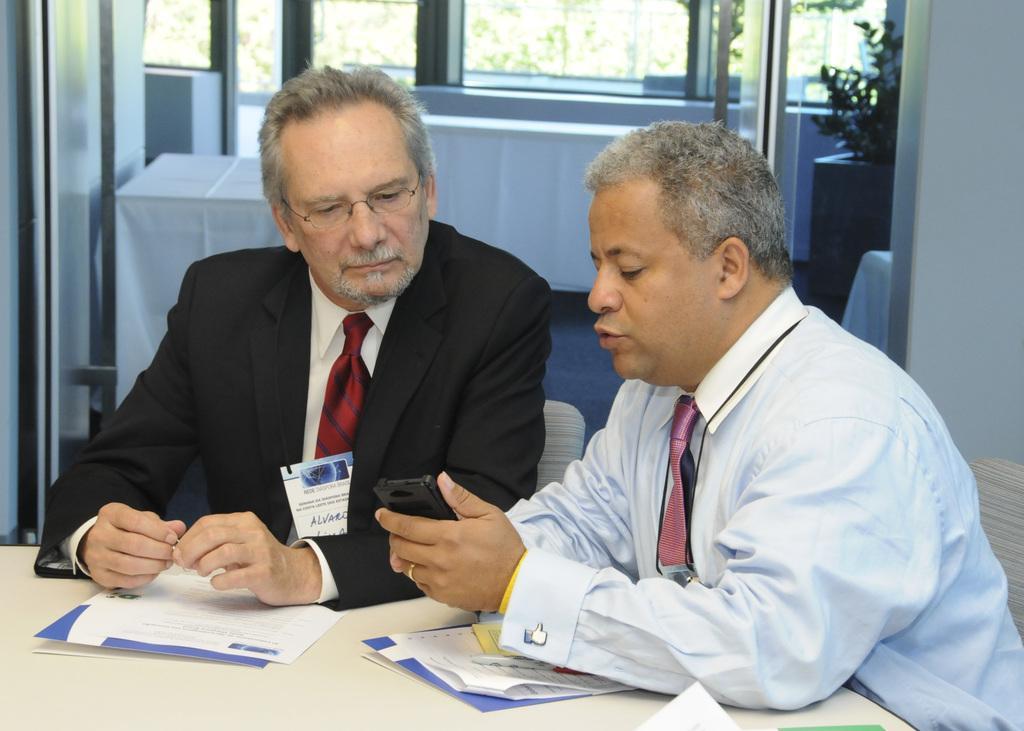Could you give a brief overview of what you see in this image? In this image there are two people sitting on their chairs, in front of them there is a table with some papers and files on it, behind them there are a few more tables and a plant pot, there is a glass window through which we can see there are trees. 